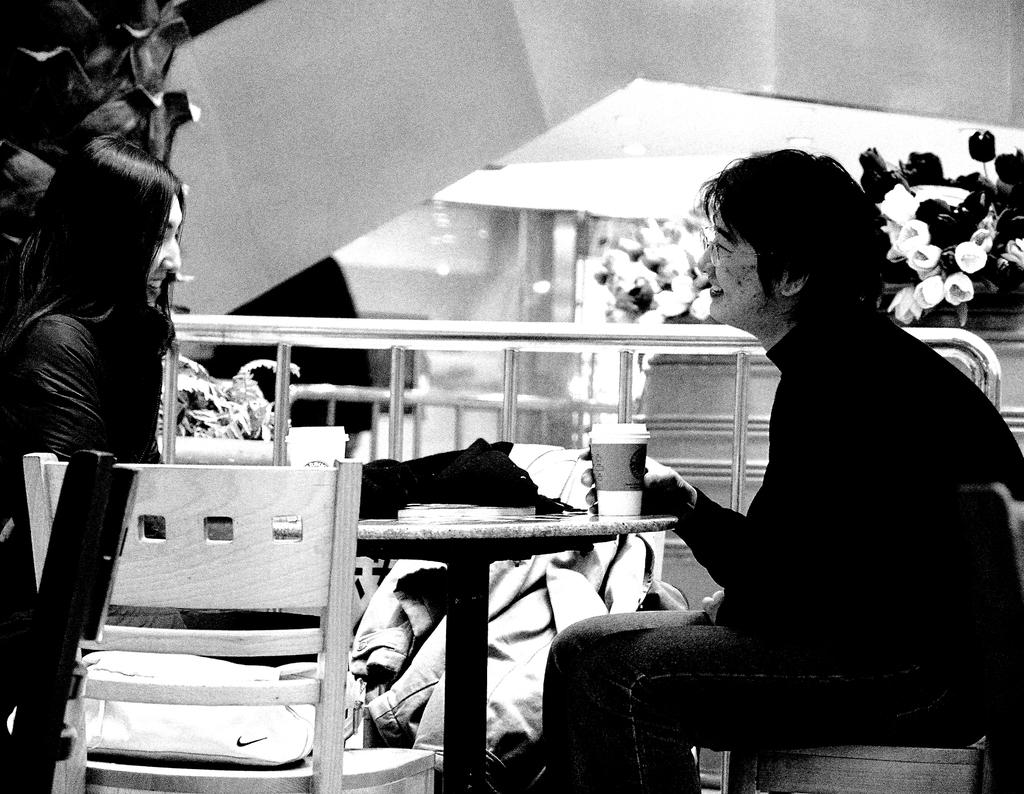What is the person on the right side of the image doing? The person is sitting on the right side of the image. What is the person wearing? The person is wearing a black dress. What is the person holding in the image? The person is holding a cup on a table. What can be seen on the left side of the image? There is a beautiful girl sitting on the left side of the image. What type of toy is the person playing with on the left side of the image? There is no toy present in the image; the person on the left side is a beautiful girl sitting. What day of the week is depicted in the image? The day of the week is not mentioned in the image or the provided facts. 